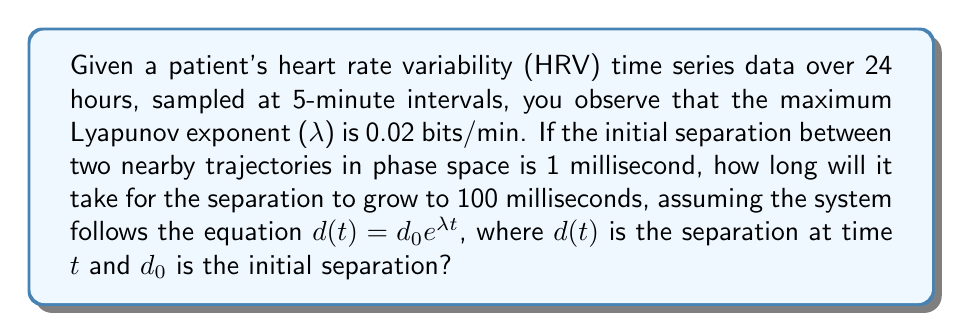Can you answer this question? To solve this problem, we'll use the equation for the growth of separation in chaotic systems:

$d(t) = d_0 e^{\lambda t}$

Where:
- $d(t)$ is the separation at time $t$
- $d_0$ is the initial separation
- $\lambda$ is the Lyapunov exponent
- $t$ is the time

Given:
- $\lambda = 0.02$ bits/min
- $d_0 = 1$ ms
- $d(t) = 100$ ms (target separation)

Step 1: Substitute the values into the equation and solve for $t$:
$100 = 1 \cdot e^{0.02t}$

Step 2: Take the natural logarithm of both sides:
$\ln(100) = \ln(e^{0.02t})$
$4.6052 = 0.02t$

Step 3: Solve for $t$:
$t = \frac{4.6052}{0.02} = 230.26$ minutes

Therefore, it will take approximately 230.26 minutes for the separation to grow from 1 ms to 100 ms.
Answer: 230.26 minutes 